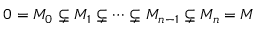Convert formula to latex. <formula><loc_0><loc_0><loc_500><loc_500>0 = M _ { 0 } \subsetneq M _ { 1 } \subsetneq \cdots \subsetneq M _ { n - 1 } \subsetneq M _ { n } = M</formula> 